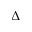Convert formula to latex. <formula><loc_0><loc_0><loc_500><loc_500>\Delta</formula> 